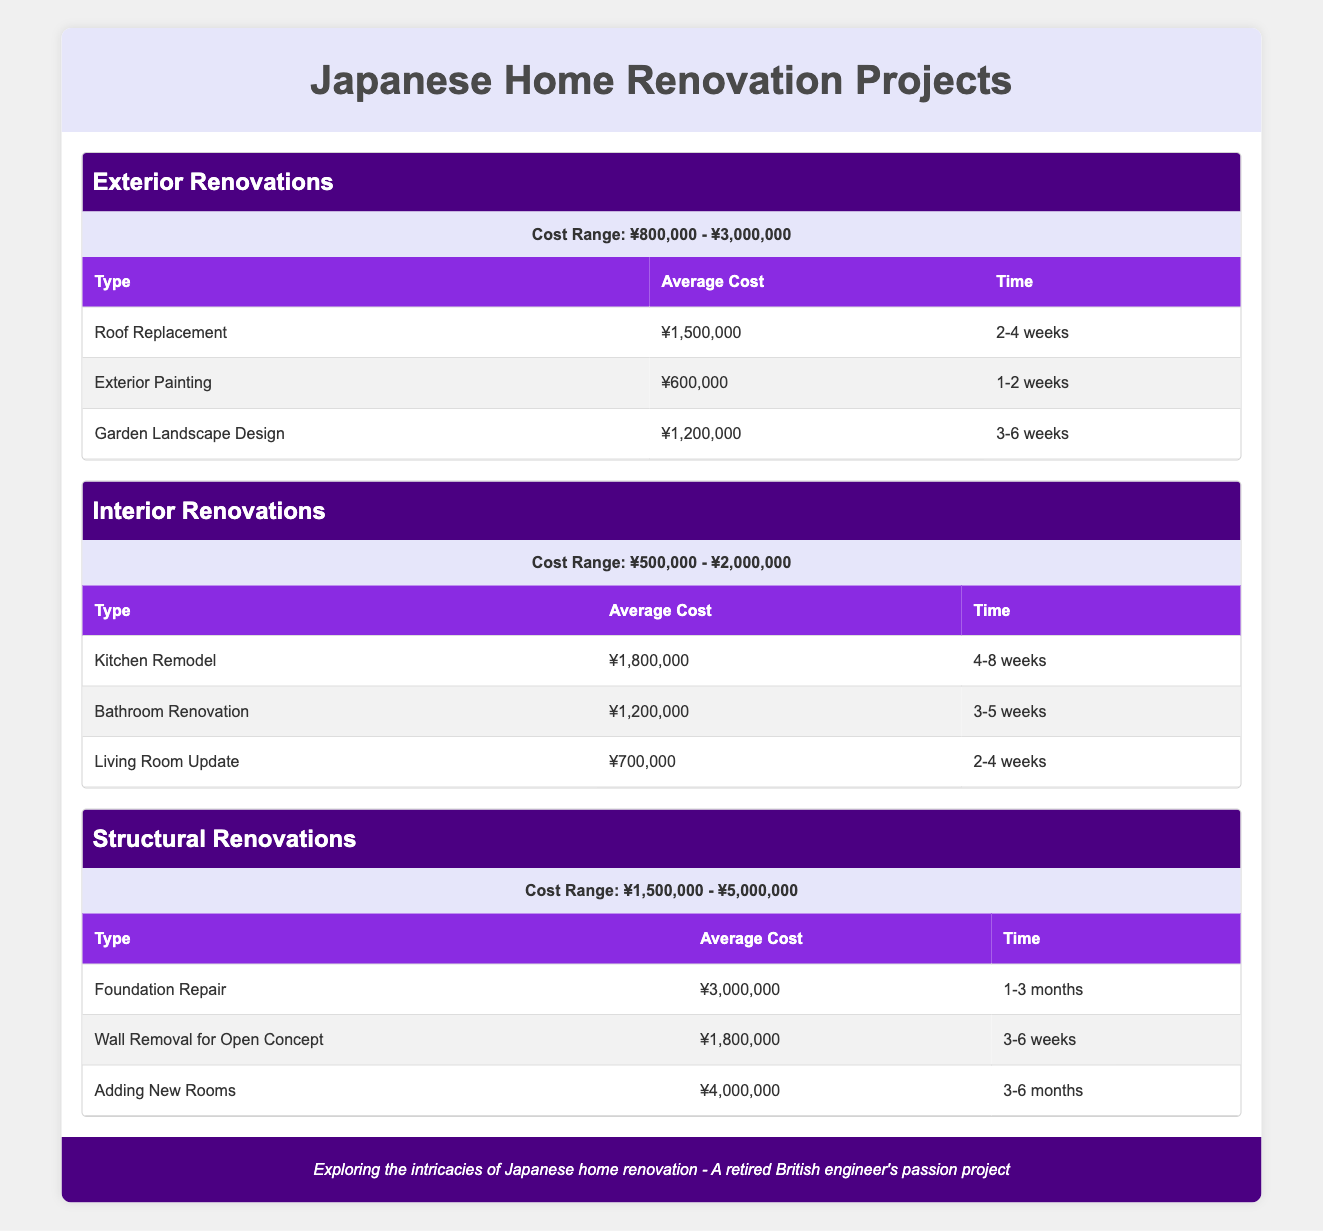What is the average cost of a Roof Replacement? The table directly states that the average cost for a Roof Replacement is ¥1,500,000.
Answer: ¥1,500,000 What is the time required for a Bathroom Renovation? According to the table, the time for a Bathroom Renovation is listed as 3-5 weeks.
Answer: 3-5 weeks Which renovation type has the highest cost range? In the table, Structural Renovations have a cost range of ¥1,500,000 - ¥5,000,000, which is higher than both other renovation types.
Answer: Structural Renovations Is the average cost of a Living Room Update less than ¥700,000? The table shows that the average cost for a Living Room Update is ¥700,000, so the statement is false.
Answer: False What is the total cost range for Exterior Renovations and Interior Renovations combined? The cost range for Exterior Renovations is ¥800,000 - ¥3,000,000 and for Interior Renovations is ¥500,000 - ¥2,000,000. The combined ranges do not sum directly, but the lowest range starts at ¥500,000 and the highest reaches ¥3,000,000.
Answer: ¥500,000 - ¥3,000,000 Are all projects under Structural Renovations expected to take longer than 3 weeks? The table indicates that both foundation repair (1-3 months) and wall removal (3-6 weeks) take longer than 3 weeks, while adding new rooms (3-6 months) also exceeds 3 weeks. Thus, the statement is true.
Answer: True What is the average cost difference between Kitchen Remodel and adding new rooms? The average cost for a Kitchen Remodel is ¥1,800,000 and for adding new rooms is ¥4,000,000. The difference is calculated as ¥4,000,000 - ¥1,800,000 = ¥2,200,000.
Answer: ¥2,200,000 How long would it take to complete the combination of a Garden Landscape Design and a Living Room Update? The time for Garden Landscape Design is 3-6 weeks and for Living Room Update is 2-4 weeks, which cannot be simply combined since they can be worked on simultaneously. The longer estimate would dominate, which is 6 weeks.
Answer: Up to 6 weeks What is the cost range for all renovation projects combined? Exterior Renovations range from ¥800,000 to ¥3,000,000, Interior Renovations from ¥500,000 to ¥2,000,000, and Structural Renovations from ¥1,500,000 to ¥5,000,000. To find the combined range, take the lowest starting point from Interior Renovations (¥500,000) and the highest end from Structural Renovations (¥5,000,000).
Answer: ¥500,000 - ¥5,000,000 